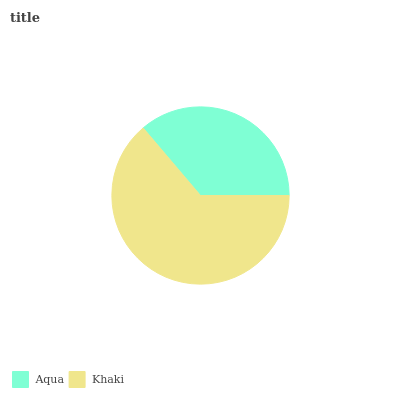Is Aqua the minimum?
Answer yes or no. Yes. Is Khaki the maximum?
Answer yes or no. Yes. Is Khaki the minimum?
Answer yes or no. No. Is Khaki greater than Aqua?
Answer yes or no. Yes. Is Aqua less than Khaki?
Answer yes or no. Yes. Is Aqua greater than Khaki?
Answer yes or no. No. Is Khaki less than Aqua?
Answer yes or no. No. Is Khaki the high median?
Answer yes or no. Yes. Is Aqua the low median?
Answer yes or no. Yes. Is Aqua the high median?
Answer yes or no. No. Is Khaki the low median?
Answer yes or no. No. 